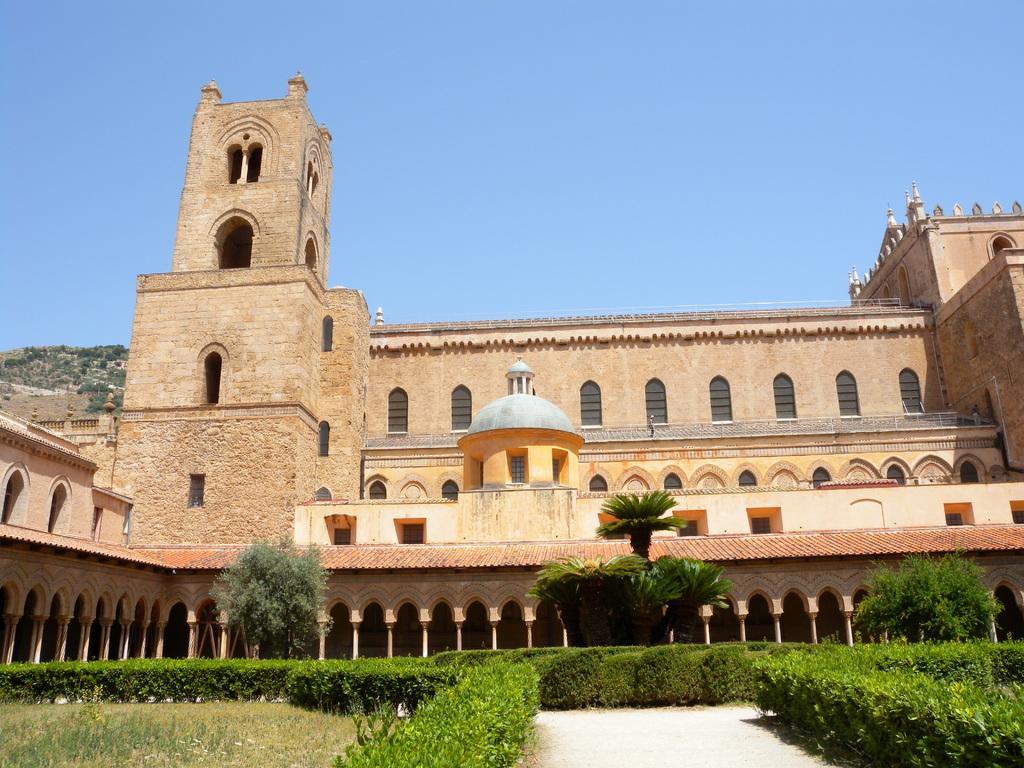In one or two sentences, can you explain what this image depicts? In the image there is a fort and in front of the fort there is a beautiful garden with trees and plants. 